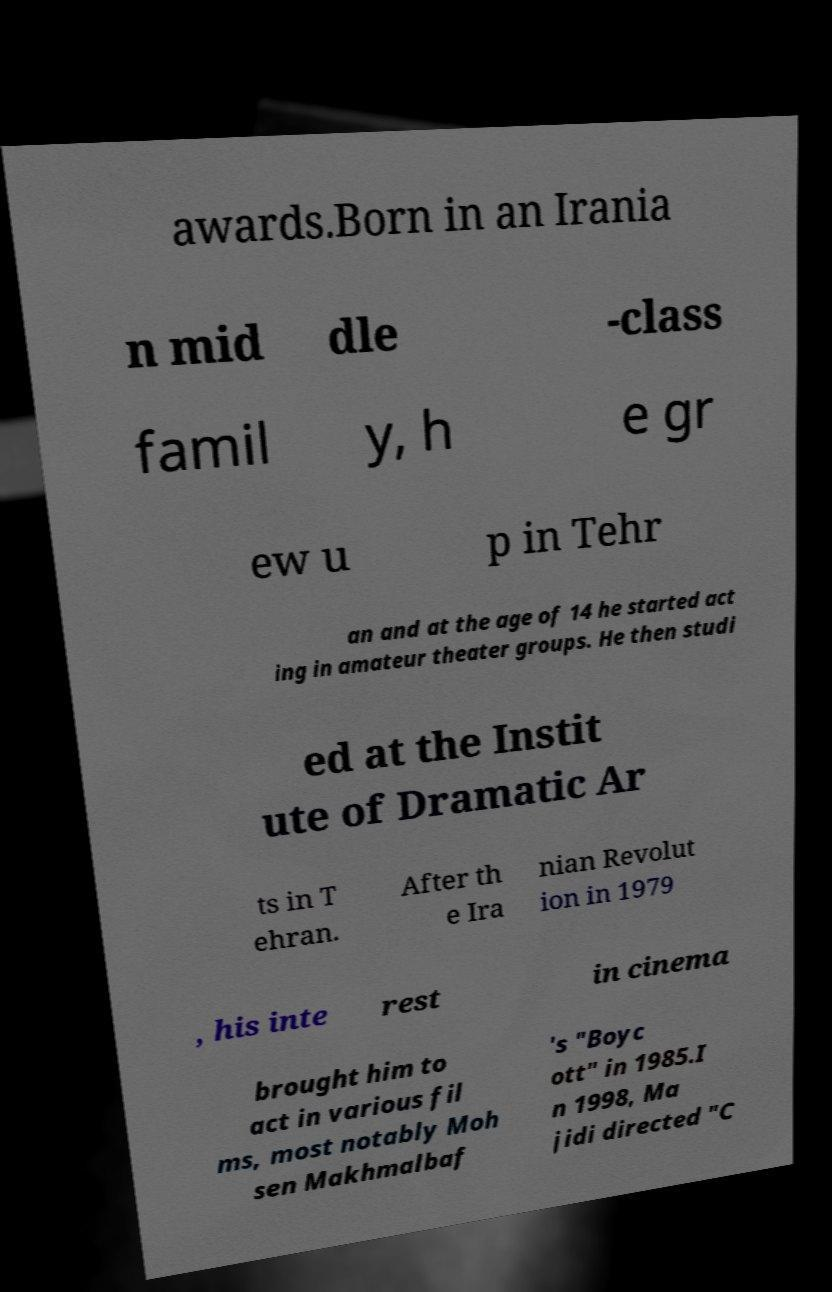What messages or text are displayed in this image? I need them in a readable, typed format. awards.Born in an Irania n mid dle -class famil y, h e gr ew u p in Tehr an and at the age of 14 he started act ing in amateur theater groups. He then studi ed at the Instit ute of Dramatic Ar ts in T ehran. After th e Ira nian Revolut ion in 1979 , his inte rest in cinema brought him to act in various fil ms, most notably Moh sen Makhmalbaf 's "Boyc ott" in 1985.I n 1998, Ma jidi directed "C 